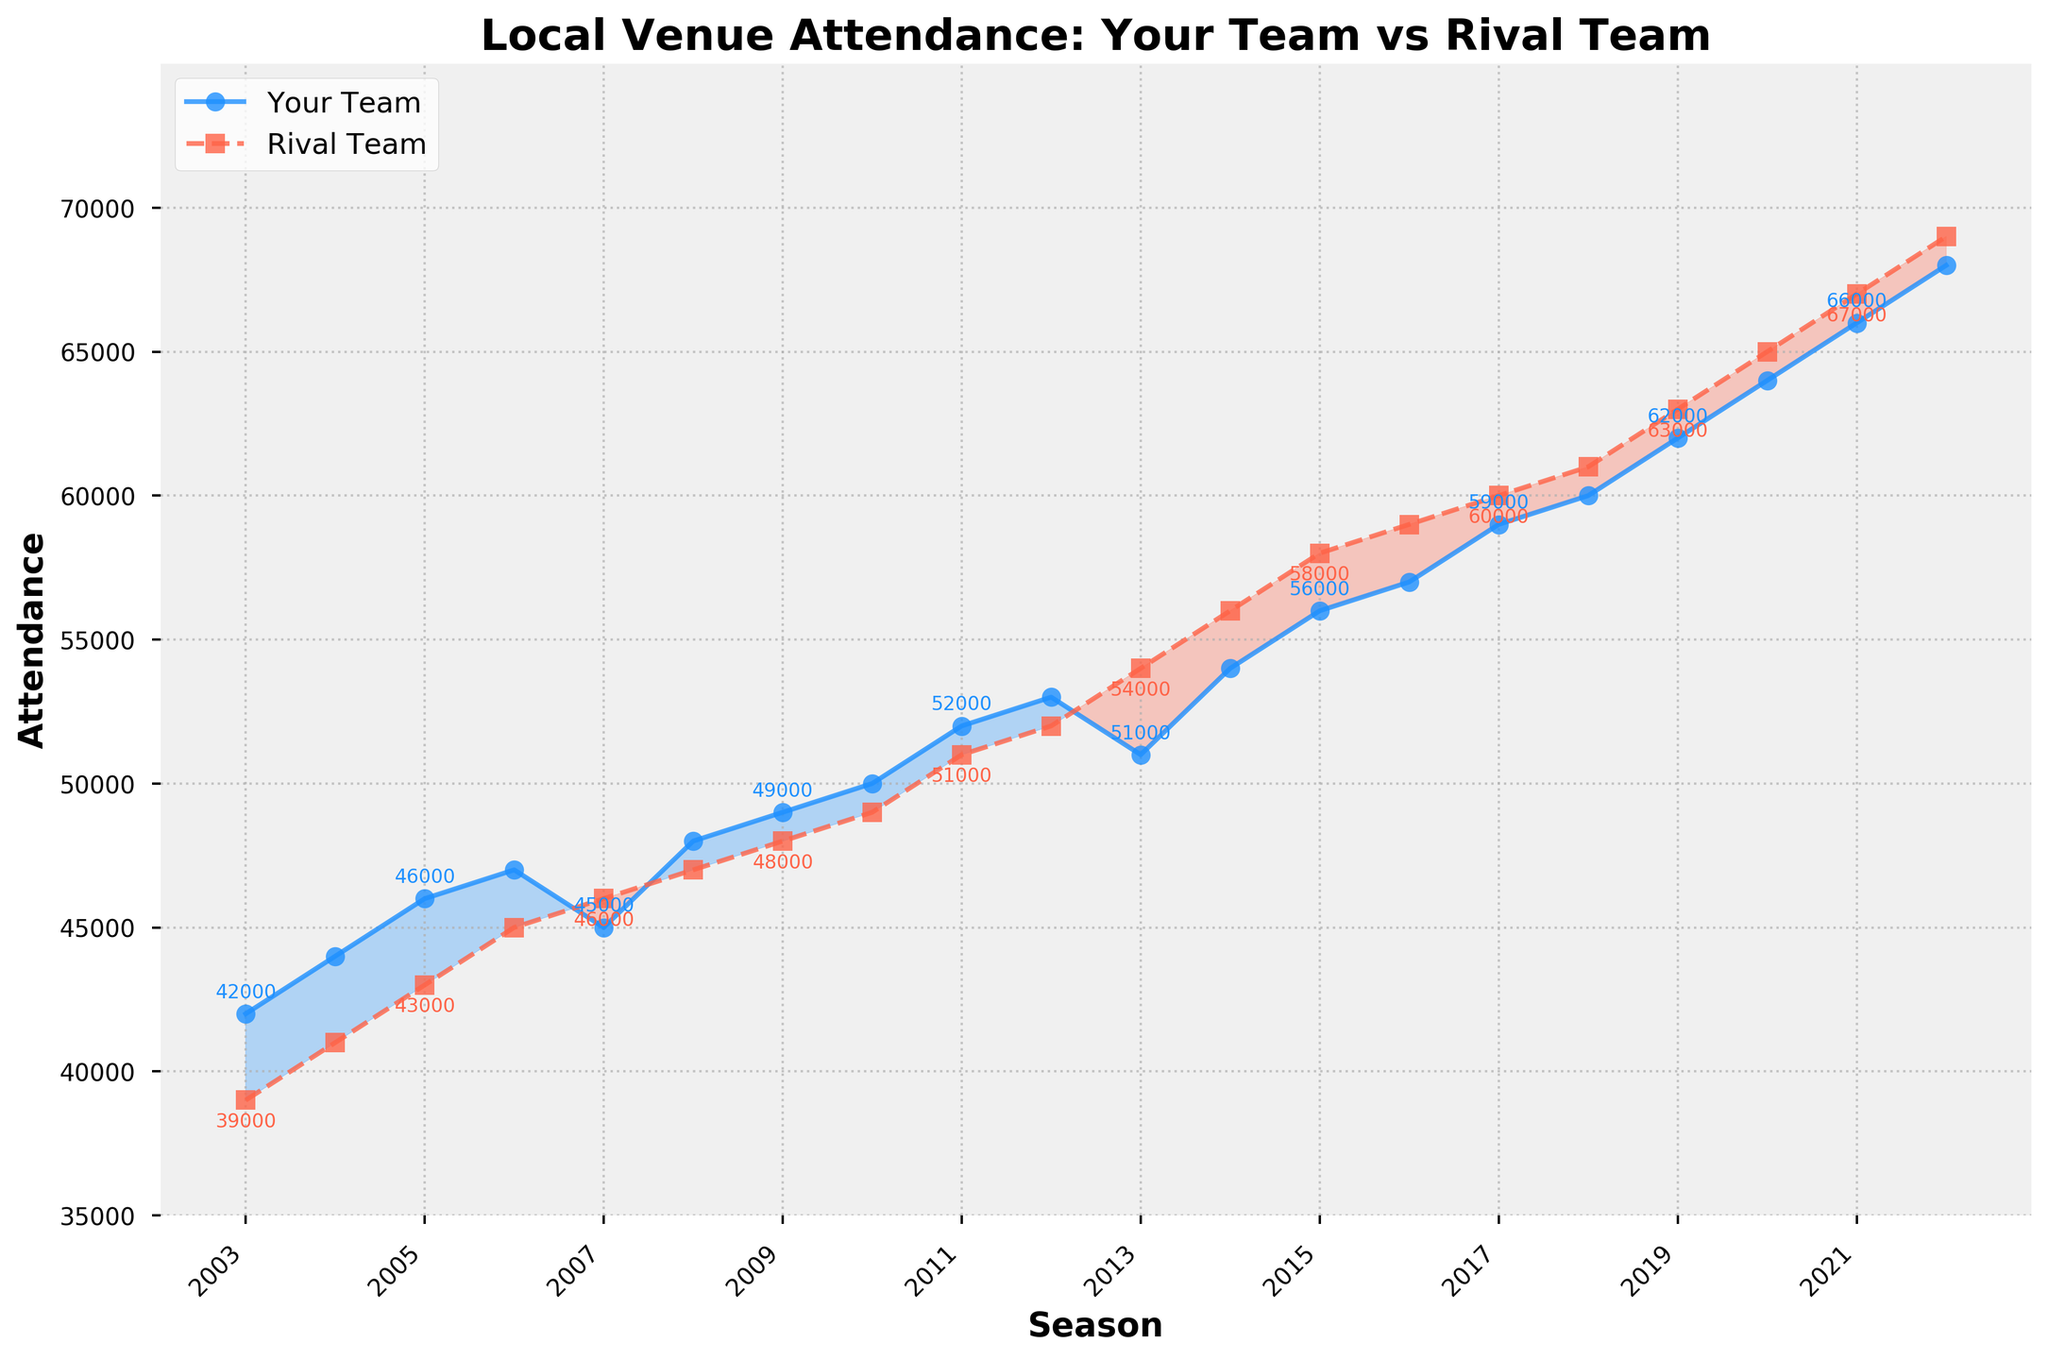What's the title of the plot? The title of the plot is displayed at the top and reads "Local Venue Attendance: Your Team vs Rival Team."
Answer: Local Venue Attendance: Your Team vs Rival Team What is the attendance for your team in the year 2010? By locating the year 2010 on the x-axis and following the line corresponding to your team's attendance, it reaches the point representing 50,000.
Answer: 50,000 In which seasons did the rival team's attendance surpass your team's? Observe the regions where the rival team's line (dashed) is above your team's line (solid). This occurs in the seasons 2007, 2013-2017.
Answer: 2007, 2013-2017 What is the range of the y-axis? The y-axis ranges from the lowest visible value to the highest, which is 35,000 to 75,000.
Answer: 35,000 to 75,000 Which team had a higher attendance in the year 2022 and by how much? In 2022, the attendance for your team was 68,000 and for the rival team was 69,000. The rival team had a higher attendance by 1,000.
Answer: Rival team, by 1,000 What is the overall trend in attendance for both teams over the 20 years? Both your team and the rival team's attendances generally show an increasing trend over the 20 years, indicated by their upward slopes.
Answer: Increasing What's the average attendance for your team over the 20 years? Add up all attendance values for your team and divide by the number of seasons (20). (42,000 + 44,000 + ... + 68,000) / 20 = 55,000.
Answer: 55,000 Between which consecutive seasons did your team's attendance increase the most? Calculate the difference between the attendance values for consecutive seasons and identify the largest increase. The largest increase happened between 2011 (52,000) and 2012 (53,000), hence a difference of 10,000.
Answer: 2011 and 2012, by 10,000 